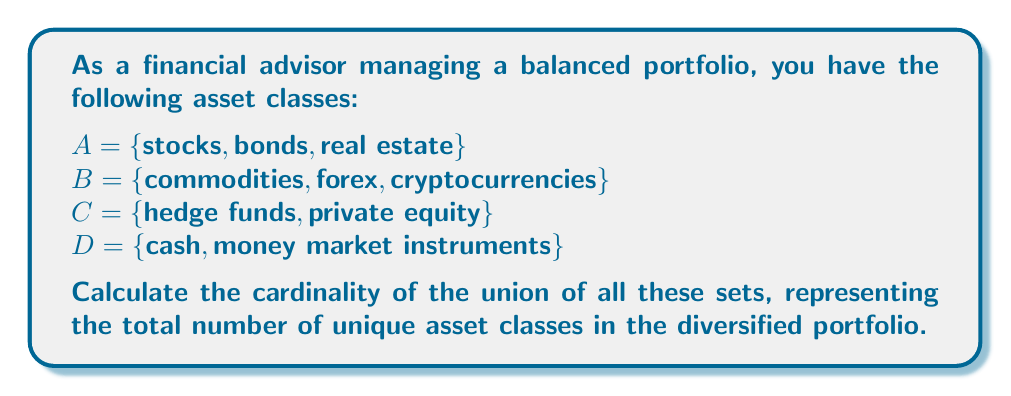Solve this math problem. To solve this problem, we need to find the cardinality of the union of sets A, B, C, and D. Let's approach this step-by-step:

1. First, let's write out the union of all sets:
   $$ A \cup B \cup C \cup D $$

2. Now, let's list all unique elements in this union:
   {stocks, bonds, real estate, commodities, forex, cryptocurrencies, hedge funds, private equity, cash, money market instruments}

3. To find the cardinality, we simply count the number of unique elements in this union:

   $$ |A \cup B \cup C \cup D| = 10 $$

4. We can verify this by counting the elements in each set:
   $$ |A| = 3, |B| = 3, |C| = 2, |D| = 2 $$

5. Note that the sum of individual set cardinalities (3 + 3 + 2 + 2 = 10) equals the cardinality of the union. This is because there are no overlapping elements between the sets, making them pairwise disjoint.

6. In set theory, this property is expressed as:
   $$ |A \cup B \cup C \cup D| = |A| + |B| + |C| + |D| $$
   when A, B, C, and D are pairwise disjoint.

Therefore, the cardinality of the union, representing the total number of unique asset classes in the diversified portfolio, is 10.
Answer: 10 